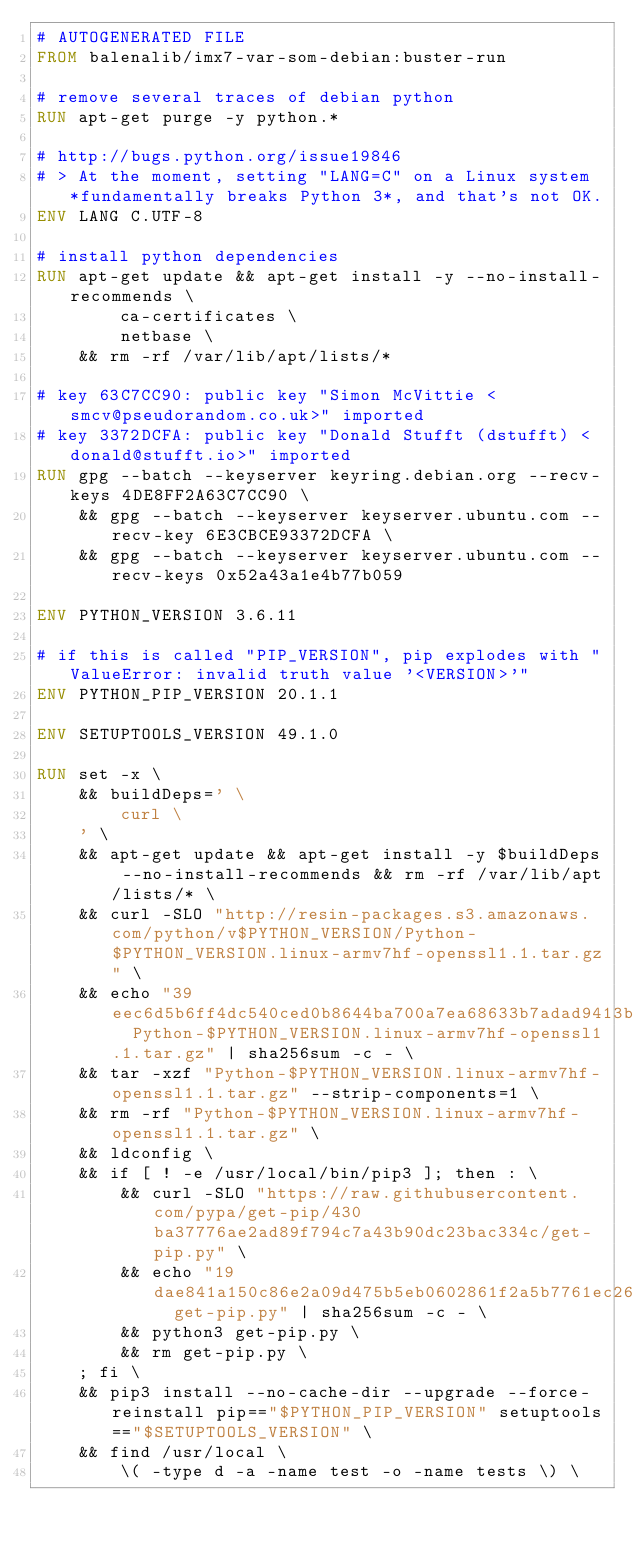<code> <loc_0><loc_0><loc_500><loc_500><_Dockerfile_># AUTOGENERATED FILE
FROM balenalib/imx7-var-som-debian:buster-run

# remove several traces of debian python
RUN apt-get purge -y python.*

# http://bugs.python.org/issue19846
# > At the moment, setting "LANG=C" on a Linux system *fundamentally breaks Python 3*, and that's not OK.
ENV LANG C.UTF-8

# install python dependencies
RUN apt-get update && apt-get install -y --no-install-recommends \
		ca-certificates \
		netbase \
	&& rm -rf /var/lib/apt/lists/*

# key 63C7CC90: public key "Simon McVittie <smcv@pseudorandom.co.uk>" imported
# key 3372DCFA: public key "Donald Stufft (dstufft) <donald@stufft.io>" imported
RUN gpg --batch --keyserver keyring.debian.org --recv-keys 4DE8FF2A63C7CC90 \
	&& gpg --batch --keyserver keyserver.ubuntu.com --recv-key 6E3CBCE93372DCFA \
	&& gpg --batch --keyserver keyserver.ubuntu.com --recv-keys 0x52a43a1e4b77b059

ENV PYTHON_VERSION 3.6.11

# if this is called "PIP_VERSION", pip explodes with "ValueError: invalid truth value '<VERSION>'"
ENV PYTHON_PIP_VERSION 20.1.1

ENV SETUPTOOLS_VERSION 49.1.0

RUN set -x \
	&& buildDeps=' \
		curl \
	' \
	&& apt-get update && apt-get install -y $buildDeps --no-install-recommends && rm -rf /var/lib/apt/lists/* \
	&& curl -SLO "http://resin-packages.s3.amazonaws.com/python/v$PYTHON_VERSION/Python-$PYTHON_VERSION.linux-armv7hf-openssl1.1.tar.gz" \
	&& echo "39eec6d5b6ff4dc540ced0b8644ba700a7ea68633b7adad9413b6fee6f1110fa  Python-$PYTHON_VERSION.linux-armv7hf-openssl1.1.tar.gz" | sha256sum -c - \
	&& tar -xzf "Python-$PYTHON_VERSION.linux-armv7hf-openssl1.1.tar.gz" --strip-components=1 \
	&& rm -rf "Python-$PYTHON_VERSION.linux-armv7hf-openssl1.1.tar.gz" \
	&& ldconfig \
	&& if [ ! -e /usr/local/bin/pip3 ]; then : \
		&& curl -SLO "https://raw.githubusercontent.com/pypa/get-pip/430ba37776ae2ad89f794c7a43b90dc23bac334c/get-pip.py" \
		&& echo "19dae841a150c86e2a09d475b5eb0602861f2a5b7761ec268049a662dbd2bd0c  get-pip.py" | sha256sum -c - \
		&& python3 get-pip.py \
		&& rm get-pip.py \
	; fi \
	&& pip3 install --no-cache-dir --upgrade --force-reinstall pip=="$PYTHON_PIP_VERSION" setuptools=="$SETUPTOOLS_VERSION" \
	&& find /usr/local \
		\( -type d -a -name test -o -name tests \) \</code> 